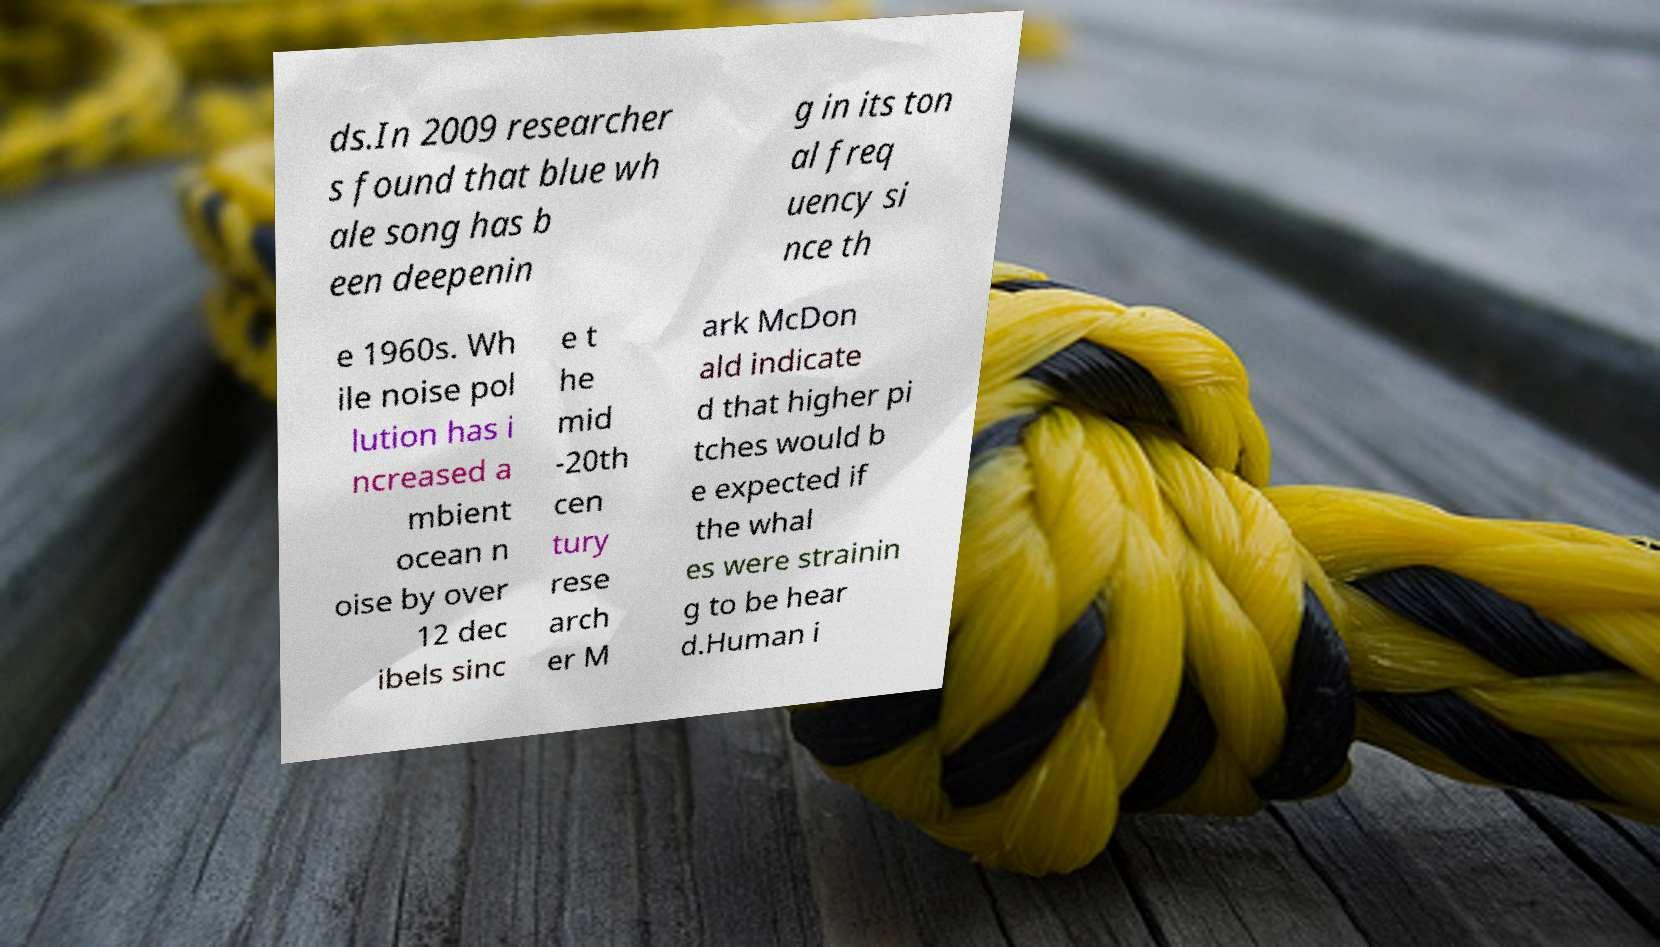I need the written content from this picture converted into text. Can you do that? ds.In 2009 researcher s found that blue wh ale song has b een deepenin g in its ton al freq uency si nce th e 1960s. Wh ile noise pol lution has i ncreased a mbient ocean n oise by over 12 dec ibels sinc e t he mid -20th cen tury rese arch er M ark McDon ald indicate d that higher pi tches would b e expected if the whal es were strainin g to be hear d.Human i 